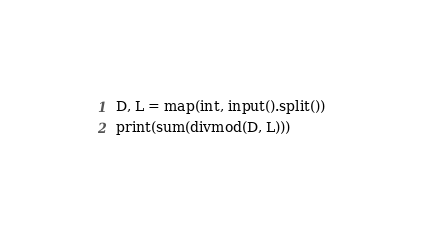Convert code to text. <code><loc_0><loc_0><loc_500><loc_500><_Python_>D, L = map(int, input().split())
print(sum(divmod(D, L)))</code> 